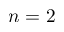Convert formula to latex. <formula><loc_0><loc_0><loc_500><loc_500>n = 2</formula> 